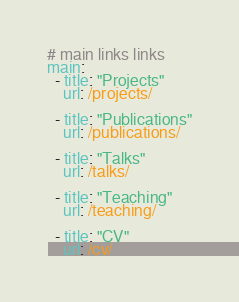<code> <loc_0><loc_0><loc_500><loc_500><_YAML_># main links links
main:
  - title: "Projects"
    url: /projects/
    
  - title: "Publications"
    url: /publications/

  - title: "Talks"
    url: /talks/    

  - title: "Teaching"
    url: /teaching/    
    
  - title: "CV"
    url: /cv/
</code> 